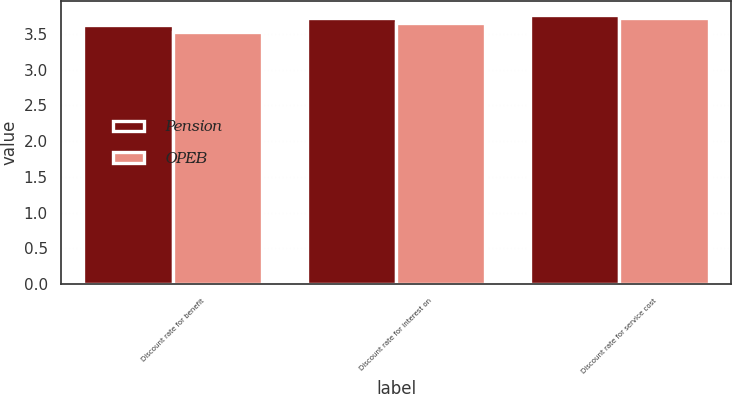Convert chart to OTSL. <chart><loc_0><loc_0><loc_500><loc_500><stacked_bar_chart><ecel><fcel>Discount rate for benefit<fcel>Discount rate for interest on<fcel>Discount rate for service cost<nl><fcel>Pension<fcel>3.62<fcel>3.72<fcel>3.77<nl><fcel>OPEB<fcel>3.53<fcel>3.65<fcel>3.72<nl></chart> 